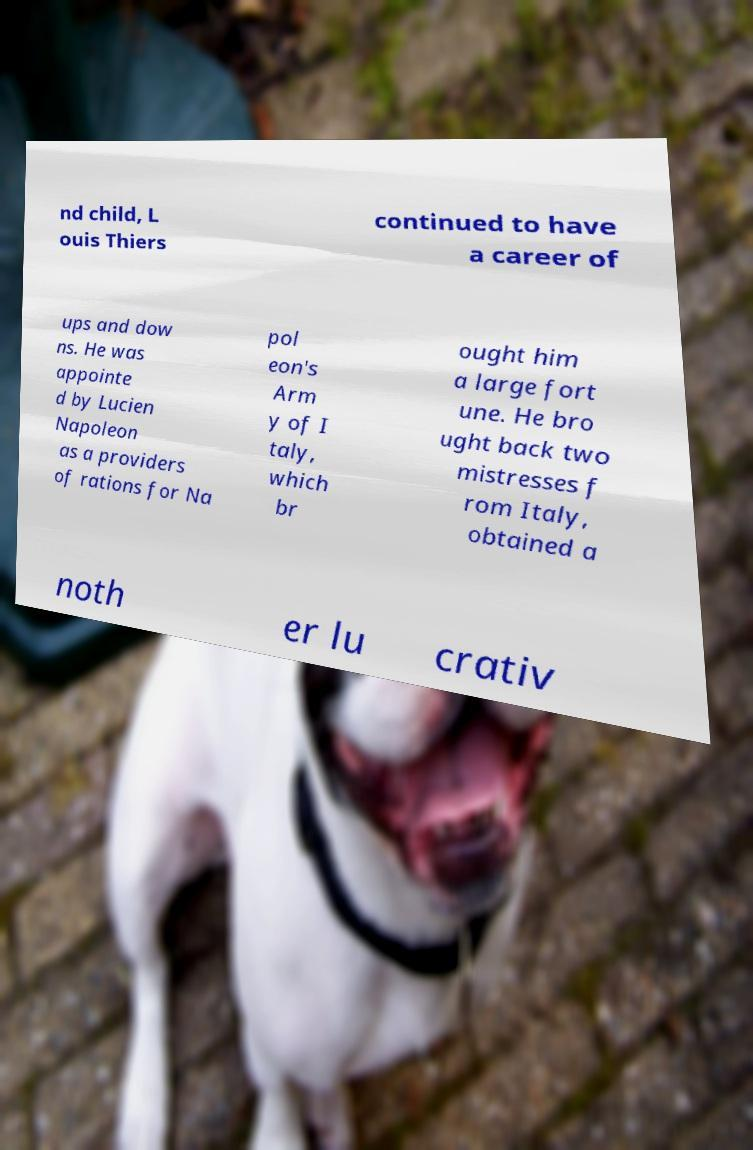Could you assist in decoding the text presented in this image and type it out clearly? nd child, L ouis Thiers continued to have a career of ups and dow ns. He was appointe d by Lucien Napoleon as a providers of rations for Na pol eon's Arm y of I taly, which br ought him a large fort une. He bro ught back two mistresses f rom Italy, obtained a noth er lu crativ 